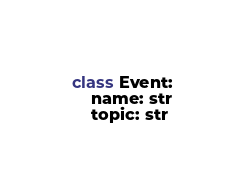Convert code to text. <code><loc_0><loc_0><loc_500><loc_500><_Python_>class Event:
    name: str
    topic: str
</code> 